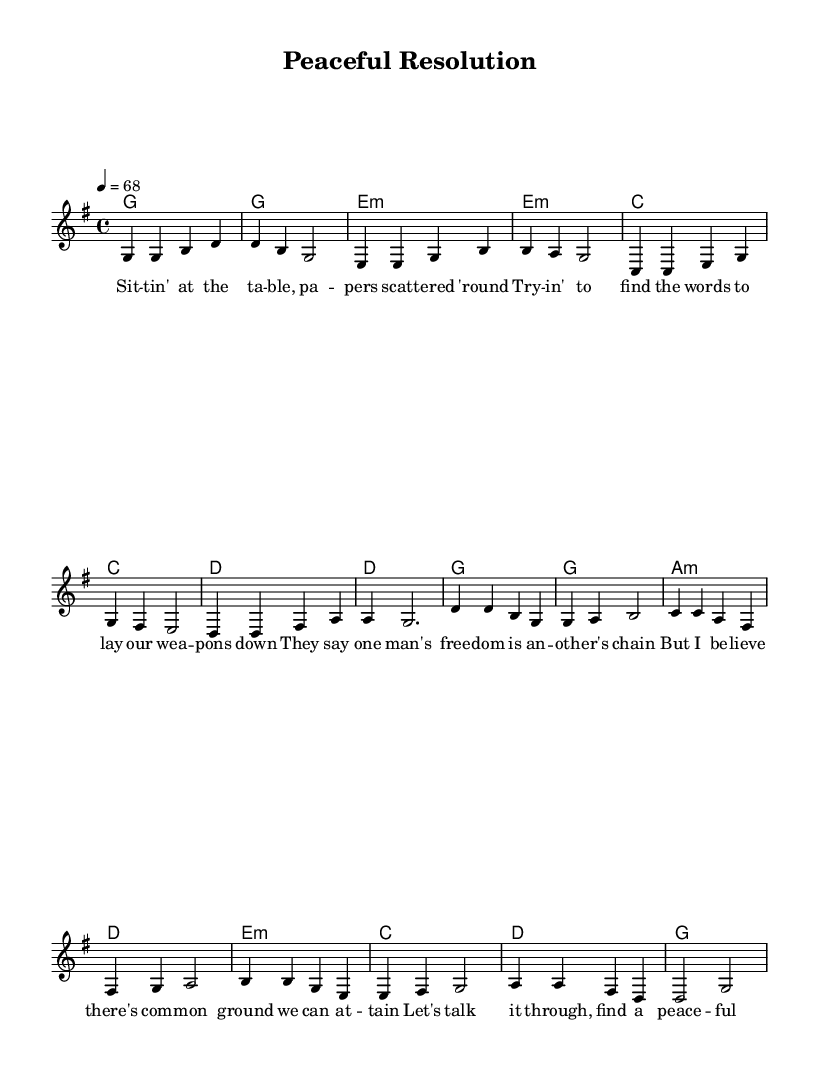What is the key signature of this music? The key signature is indicated at the beginning of the piece. In this case, it shows one sharp, which corresponds to G major.
Answer: G major What is the time signature of this music? The time signature is noted at the beginning as well, showing a 4 over 4, which means there are four beats in each measure.
Answer: 4/4 What is the tempo marking of this music? The tempo is indicated above the staff, and it shows a speed of quarter note equals sixty-eight beats per minute.
Answer: 68 How many measures are in the verse section? To determine this, we count the bars in the "melody" part under the verse section, which is indicated by the absence of the chorus label. There are eight measures in total.
Answer: 8 What type of chords are predominantly used in the verse section? By examining the chord progression in the "harmonies" part under the verse section, the chords used include major and minor chords. Notably, G major and E minor are included.
Answer: Major and minor What is the primary theme of the lyrics based on the title? The title "Peaceful Resolution" suggests themes of negotiation and seeking a common ground, as described in the lyrics, which advocate for discussions over conflict.
Answer: Negotiation How is the chorus structured in relation to the verse? The chorus follows the verse section and is characterized by a distinct lyrical message about finding a peaceful way to resolve conflicts, highlighting the shift from narrative to a call for action.
Answer: Distinct call for action 